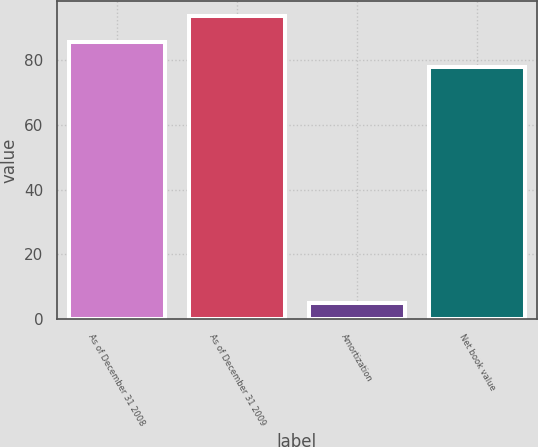<chart> <loc_0><loc_0><loc_500><loc_500><bar_chart><fcel>As of December 31 2008<fcel>As of December 31 2009<fcel>Amortization<fcel>Net book value<nl><fcel>85.8<fcel>93.6<fcel>5<fcel>78<nl></chart> 